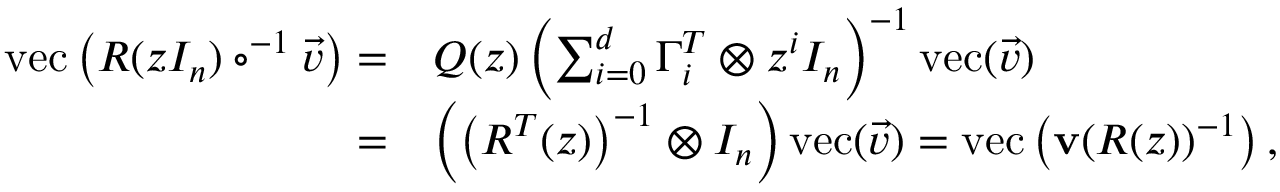<formula> <loc_0><loc_0><loc_500><loc_500>\begin{array} { r l } { v e c \left ( R ( z I _ { n } ) \circ ^ { - 1 } \vec { v } \right ) = } & { Q ( z ) \left ( \sum _ { i = 0 } ^ { d } \Gamma _ { i } ^ { T } \otimes z ^ { i } I _ { n } \right ) ^ { - 1 } v e c ( \vec { v } ) } \\ { = } & { \left ( \left ( R ^ { T } ( z ) \right ) ^ { - 1 } \otimes I _ { n } \right ) v e c ( \vec { v } ) = v e c \left ( v ( R ( z ) ) ^ { - 1 } \right ) , } \end{array}</formula> 